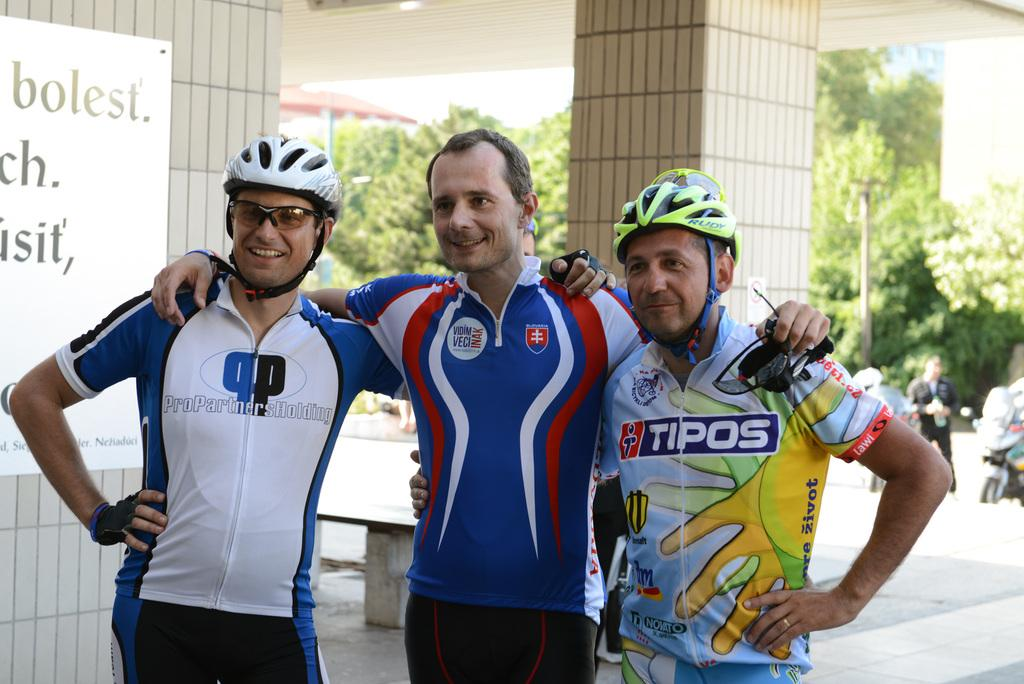Provide a one-sentence caption for the provided image. Three cyclists pose for a picture together and the man with the shirt advertising Tipos has a black and yellow helmet on his head. 